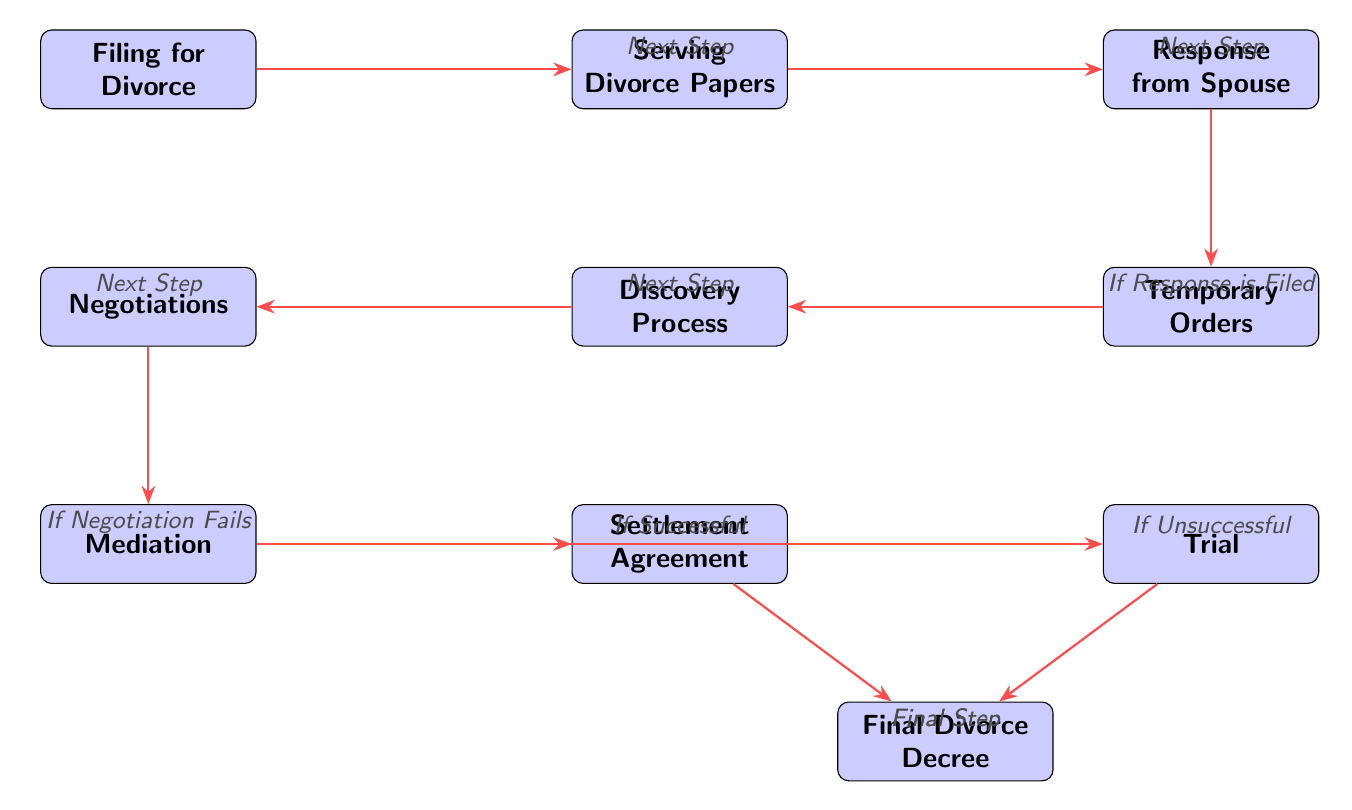What's the first step in the divorce case lifecycle? The diagram indicates that the first node is "Filing for Divorce," which starts the process.
Answer: Filing for Divorce How many main steps are there in the divorce process? Counting the nodes in the diagram shows there are 10 main steps involved in the divorce case lifecycle.
Answer: 10 What happens after "Response from Spouse"? The diagram shows that after "Response from Spouse," the next step is "Temporary Orders," only if a response is filed.
Answer: Temporary Orders What follows "Mediation" if it is successful? According to the diagram, if mediation is successful, the next step is "Settlement Agreement."
Answer: Settlement Agreement What is the last step in the divorce process? The diagram presents "Final Divorce Decree" as the last step after either "Settlement Agreement" or "Trial."
Answer: Final Divorce Decree If negotiations fail, what is the next action? The diagram indicates that if negotiations fail, the next step is to proceed to "Mediation."
Answer: Mediation How does "Serving Divorce Papers" connect to "Filing for Divorce"? The diagram shows a direct connection from "Filing for Divorce" to "Serving Divorce Papers," indicating it is the next step.
Answer: Next Step What is the direct outcome of "Trial"? The diagram notes that the final step following "Trial" is "Final Divorce Decree."
Answer: Final Divorce Decree What occurs during the "Discovery Process"? The diagram does not explicitly define the actions within "Discovery Process," but it follows "Temporary Orders."
Answer: Not specified 